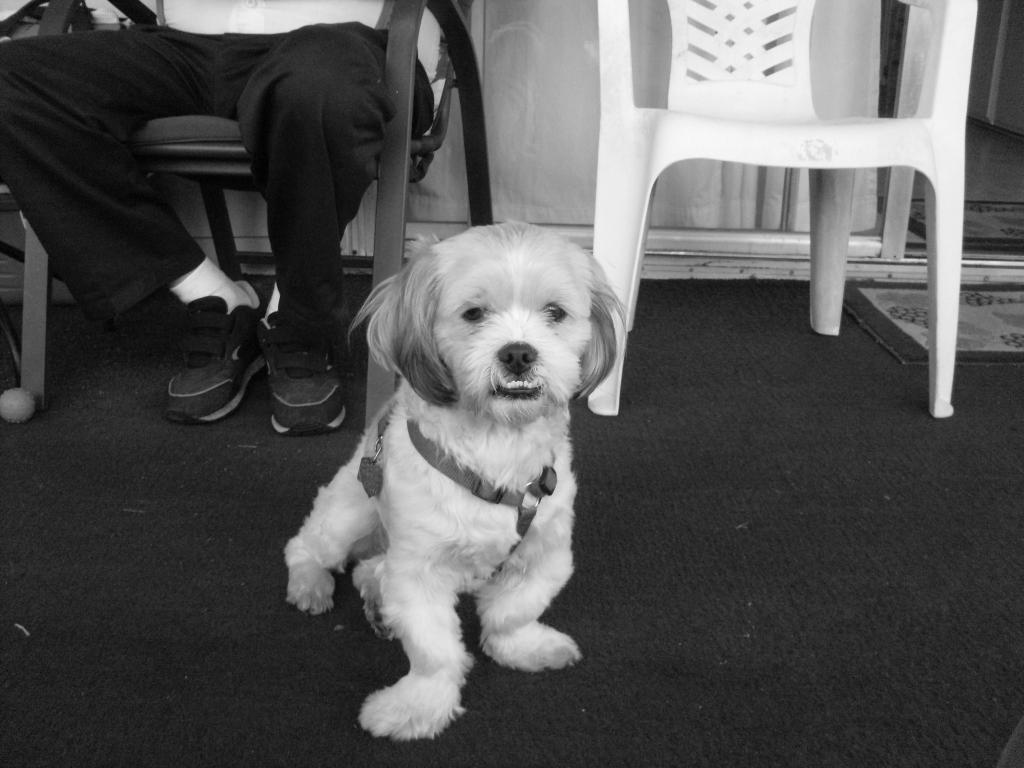What is the color scheme of the image? The image is black and white. What animal can be seen in the image? There is a dog in the image. What piece of furniture is present in the image? There is a chair in the image. What type of flooring is visible in the image? There is a carpet in the image. What is the person in the image doing? A person is sitting on the chair. What is behind the person in the image? There is a wall behind the person. How much money is on the sofa in the image? There is no sofa present in the image, and therefore no money can be found on it. What type of flock is visible in the image? There is no flock present in the image; it features a dog, a chair, a carpet, and a person sitting on the chair. 